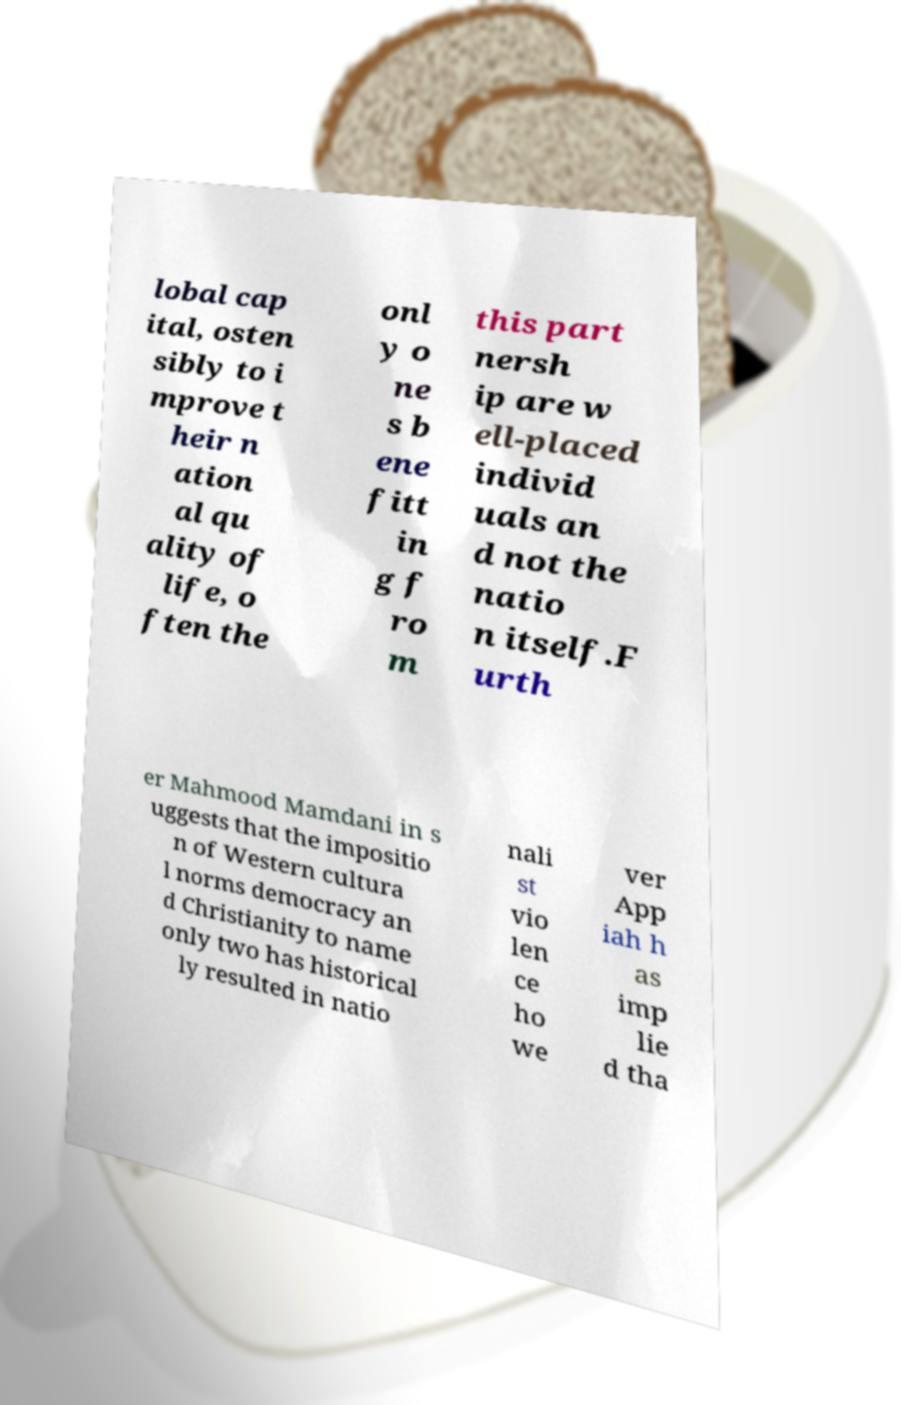Can you read and provide the text displayed in the image?This photo seems to have some interesting text. Can you extract and type it out for me? lobal cap ital, osten sibly to i mprove t heir n ation al qu ality of life, o ften the onl y o ne s b ene fitt in g f ro m this part nersh ip are w ell-placed individ uals an d not the natio n itself.F urth er Mahmood Mamdani in s uggests that the impositio n of Western cultura l norms democracy an d Christianity to name only two has historical ly resulted in natio nali st vio len ce ho we ver App iah h as imp lie d tha 